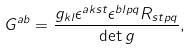<formula> <loc_0><loc_0><loc_500><loc_500>G ^ { a b } = \frac { g _ { k l } \epsilon ^ { a k s t } \epsilon ^ { b l p q } R _ { s t p q } } { \det g } ,</formula> 